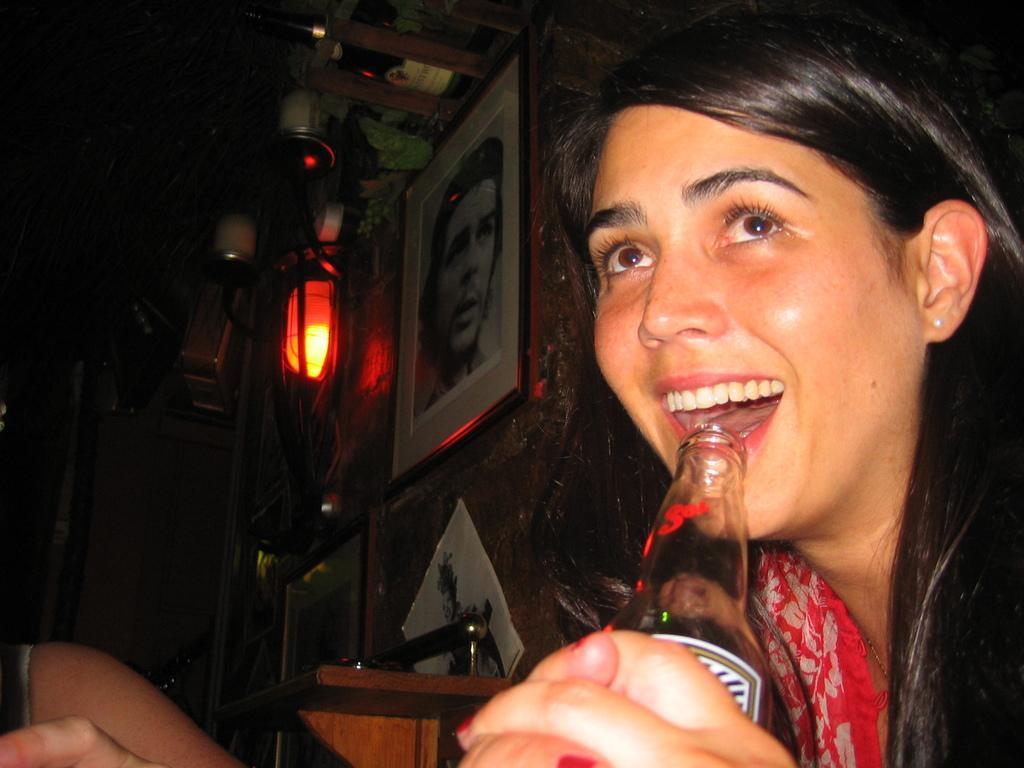Please provide a concise description of this image. On the right side of the image we can see a woman holding a bottle and smiling. The background of the image is dark where we can see photo frames on the wall and lamps. 